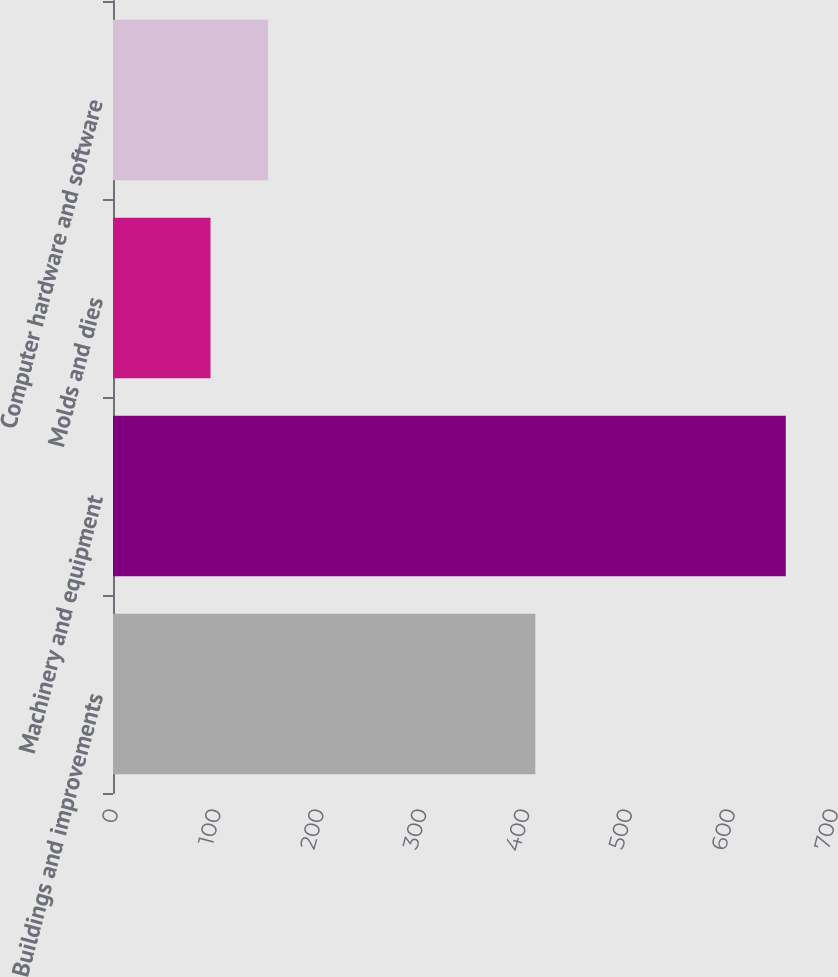Convert chart to OTSL. <chart><loc_0><loc_0><loc_500><loc_500><bar_chart><fcel>Buildings and improvements<fcel>Machinery and equipment<fcel>Molds and dies<fcel>Computer hardware and software<nl><fcel>410.6<fcel>654.1<fcel>94.8<fcel>150.73<nl></chart> 